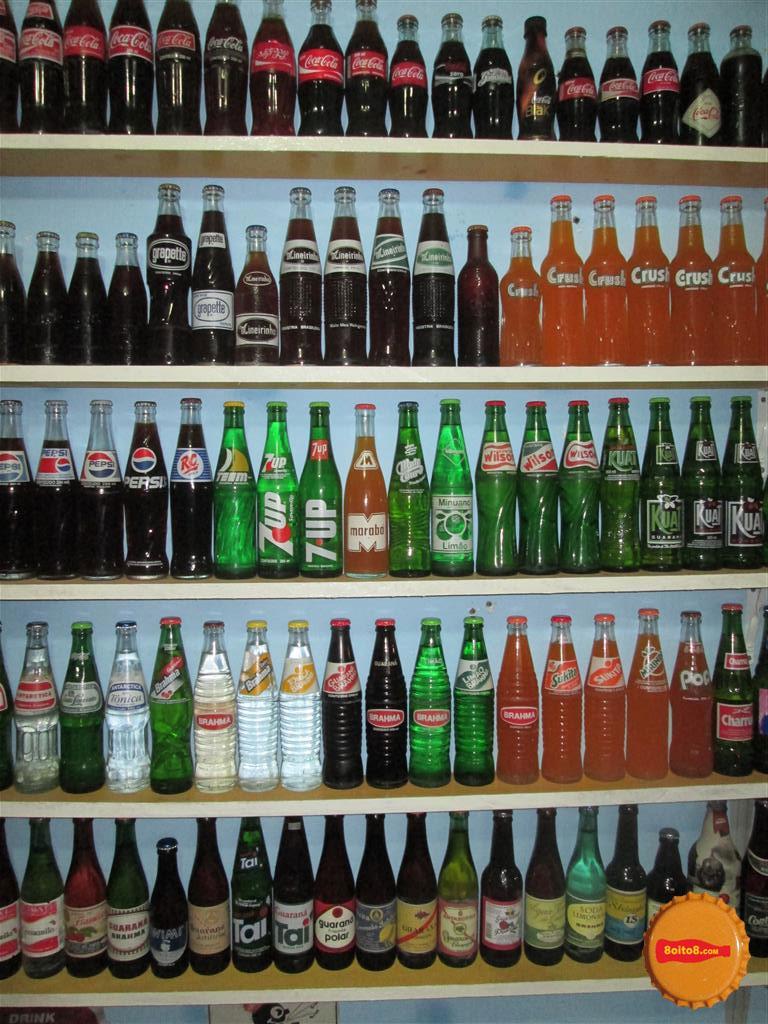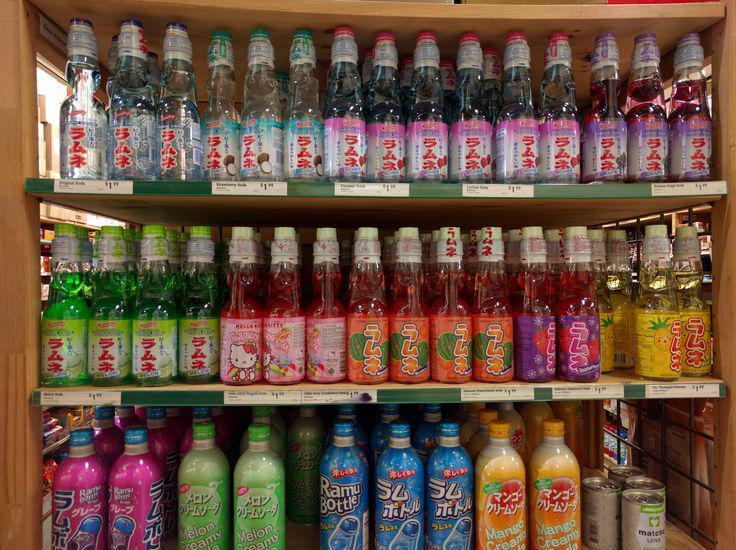The first image is the image on the left, the second image is the image on the right. Assess this claim about the two images: "There are no glass bottles in the right image.". Correct or not? Answer yes or no. No. The first image is the image on the left, the second image is the image on the right. For the images shown, is this caption "There are lots of American brand, plastic soda bottles." true? Answer yes or no. No. 